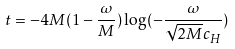Convert formula to latex. <formula><loc_0><loc_0><loc_500><loc_500>t = - 4 M ( 1 - \frac { \omega } { M } ) \log ( - \frac { \omega } { \sqrt { 2 M } c _ { H } } )</formula> 